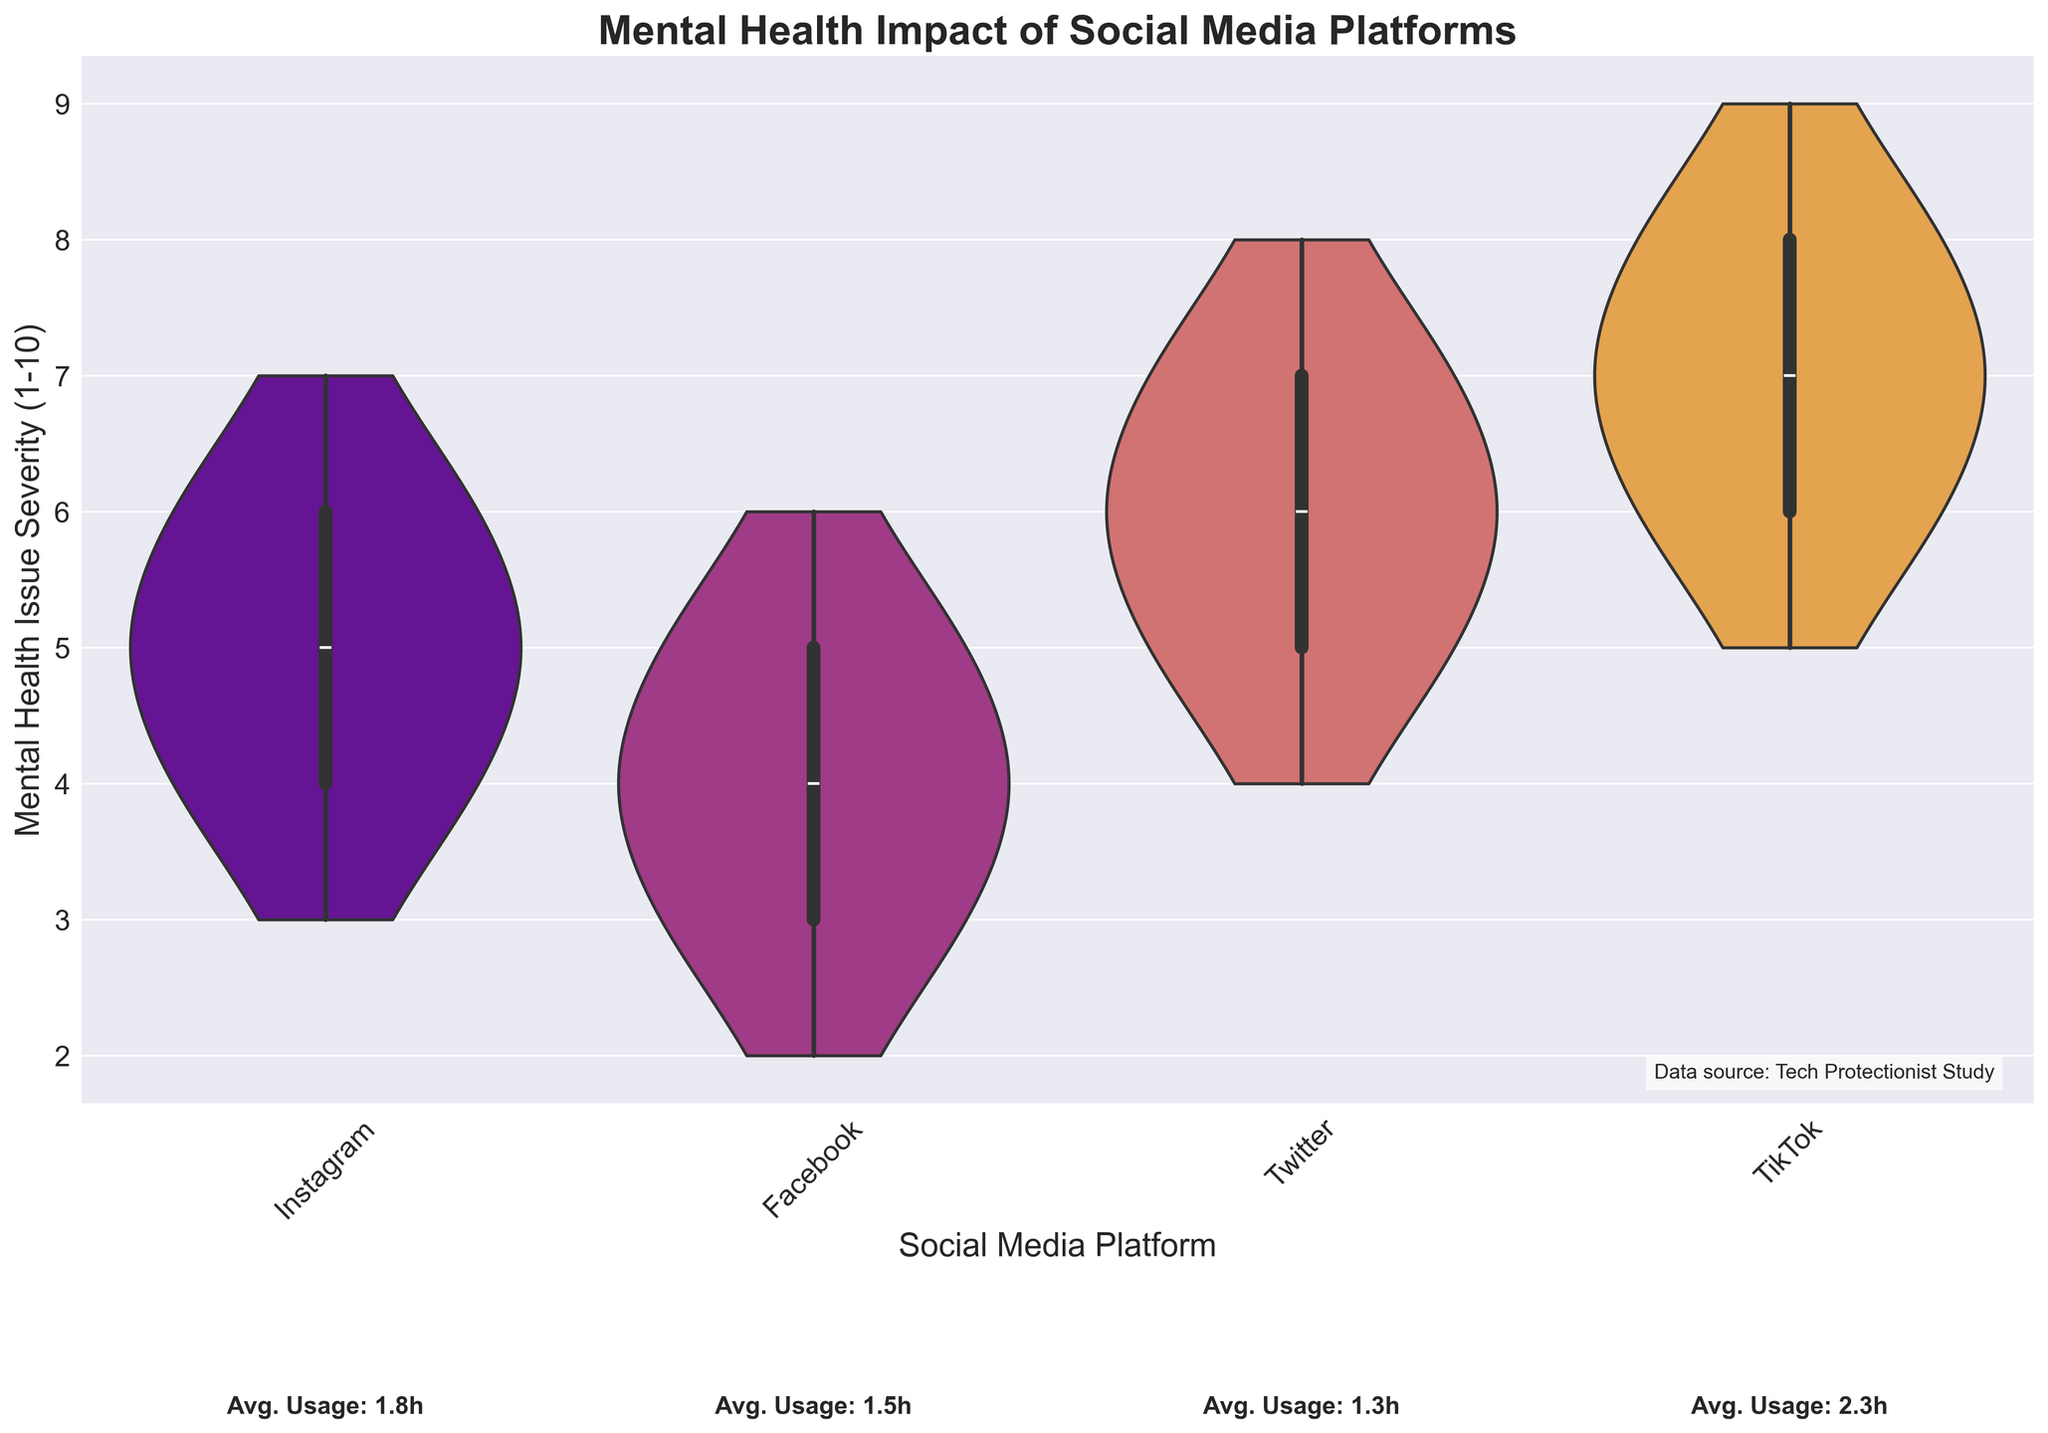What is the title of the figure? The title is clearly displayed at the top of the figure in bold text. The title often provides a summary of what the figure is about.
Answer: Mental Health Impact of Social Media Platforms Which social media platform has the highest average daily usage? According to the text annotations just below the x-axis of the figure, the average daily usage for each platform is provided. We compare these values to determine which is highest.
Answer: TikTok What is the range of mental health issue severity for Instagram? The violin plot for Instagram shows the spread of the data. The range is determined by the lowest and highest points where the violin plot tapers off.
Answer: 3 to 7 Which age cohort appears to experience the highest severity of mental health issues on TikTok? By examining the data points and spread on the violin plots and considering the average daily usage values, we can infer which age cohort aligns with the highest severity.
Answer: 19-24 How does the median mental health severity for Facebook compare to Instagram? The box plot overlay within the violin plot shows the median value as a line. We compare the position of this line for both Facebook and Instagram.
Answer: Facebook's median is lower Which platform shows the widest range of reported mental health issue severity? The range can be inferred from the width of the violin plots and the range covered by the box plot. The platform with the widest spread from low to high values is what we're looking for.
Answer: TikTok What can you infer about the correlation between daily usage and mental health issue severity for Twitter? The violin plot can suggest trends and correlations. Higher usage hours often correlate with higher reported mental health issue severity, so we assess Twitter's spread and median usage hours.
Answer: Higher usage correlates with higher severity 